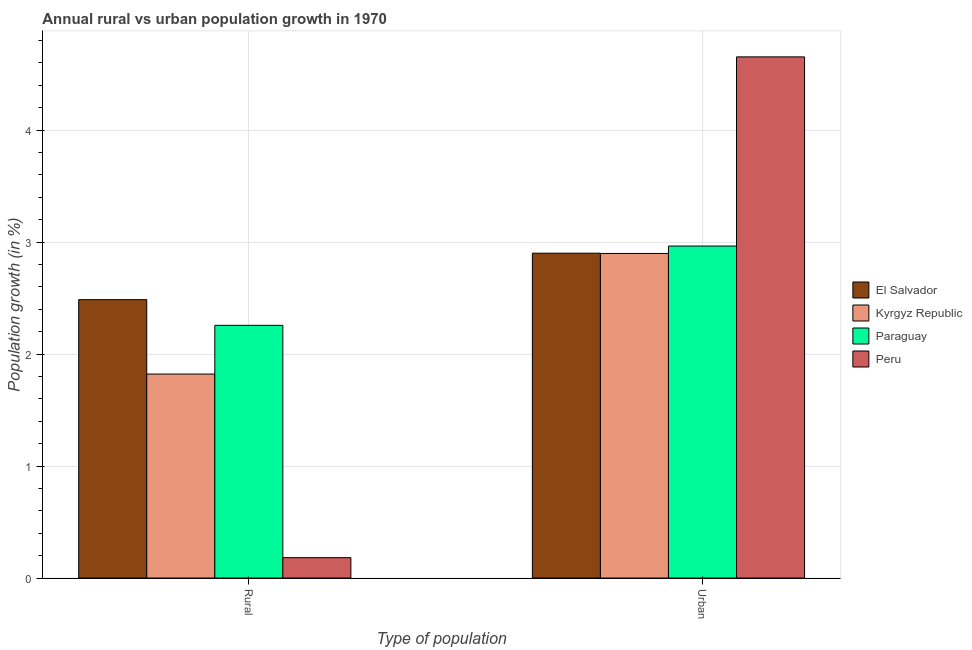How many different coloured bars are there?
Provide a short and direct response. 4. How many groups of bars are there?
Offer a very short reply. 2. Are the number of bars on each tick of the X-axis equal?
Provide a short and direct response. Yes. How many bars are there on the 2nd tick from the left?
Your response must be concise. 4. What is the label of the 2nd group of bars from the left?
Offer a terse response. Urban . What is the rural population growth in Peru?
Your response must be concise. 0.18. Across all countries, what is the maximum urban population growth?
Keep it short and to the point. 4.65. Across all countries, what is the minimum rural population growth?
Your answer should be compact. 0.18. In which country was the rural population growth minimum?
Provide a succinct answer. Peru. What is the total rural population growth in the graph?
Give a very brief answer. 6.75. What is the difference between the urban population growth in Paraguay and that in Peru?
Your answer should be very brief. -1.69. What is the difference between the rural population growth in Peru and the urban population growth in Kyrgyz Republic?
Provide a short and direct response. -2.72. What is the average urban population growth per country?
Your answer should be very brief. 3.35. What is the difference between the urban population growth and rural population growth in El Salvador?
Provide a succinct answer. 0.41. In how many countries, is the rural population growth greater than 1.8 %?
Your answer should be compact. 3. What is the ratio of the rural population growth in El Salvador to that in Paraguay?
Offer a terse response. 1.1. What does the 3rd bar from the left in Rural represents?
Make the answer very short. Paraguay. What does the 2nd bar from the right in Rural represents?
Provide a succinct answer. Paraguay. How many bars are there?
Your response must be concise. 8. Are all the bars in the graph horizontal?
Make the answer very short. No. How many countries are there in the graph?
Offer a very short reply. 4. What is the difference between two consecutive major ticks on the Y-axis?
Your answer should be very brief. 1. Are the values on the major ticks of Y-axis written in scientific E-notation?
Offer a very short reply. No. Does the graph contain any zero values?
Offer a very short reply. No. Does the graph contain grids?
Offer a very short reply. Yes. What is the title of the graph?
Offer a terse response. Annual rural vs urban population growth in 1970. What is the label or title of the X-axis?
Provide a short and direct response. Type of population. What is the label or title of the Y-axis?
Offer a terse response. Population growth (in %). What is the Population growth (in %) of El Salvador in Rural?
Ensure brevity in your answer.  2.49. What is the Population growth (in %) in Kyrgyz Republic in Rural?
Your response must be concise. 1.82. What is the Population growth (in %) of Paraguay in Rural?
Keep it short and to the point. 2.26. What is the Population growth (in %) in Peru in Rural?
Your response must be concise. 0.18. What is the Population growth (in %) in El Salvador in Urban ?
Keep it short and to the point. 2.9. What is the Population growth (in %) in Kyrgyz Republic in Urban ?
Your answer should be very brief. 2.9. What is the Population growth (in %) in Paraguay in Urban ?
Offer a terse response. 2.96. What is the Population growth (in %) of Peru in Urban ?
Offer a terse response. 4.65. Across all Type of population, what is the maximum Population growth (in %) of El Salvador?
Give a very brief answer. 2.9. Across all Type of population, what is the maximum Population growth (in %) in Kyrgyz Republic?
Keep it short and to the point. 2.9. Across all Type of population, what is the maximum Population growth (in %) in Paraguay?
Make the answer very short. 2.96. Across all Type of population, what is the maximum Population growth (in %) in Peru?
Your answer should be very brief. 4.65. Across all Type of population, what is the minimum Population growth (in %) of El Salvador?
Keep it short and to the point. 2.49. Across all Type of population, what is the minimum Population growth (in %) of Kyrgyz Republic?
Ensure brevity in your answer.  1.82. Across all Type of population, what is the minimum Population growth (in %) in Paraguay?
Give a very brief answer. 2.26. Across all Type of population, what is the minimum Population growth (in %) in Peru?
Provide a succinct answer. 0.18. What is the total Population growth (in %) of El Salvador in the graph?
Provide a succinct answer. 5.39. What is the total Population growth (in %) of Kyrgyz Republic in the graph?
Your answer should be very brief. 4.72. What is the total Population growth (in %) in Paraguay in the graph?
Your answer should be very brief. 5.22. What is the total Population growth (in %) in Peru in the graph?
Give a very brief answer. 4.84. What is the difference between the Population growth (in %) of El Salvador in Rural and that in Urban ?
Your answer should be very brief. -0.41. What is the difference between the Population growth (in %) of Kyrgyz Republic in Rural and that in Urban ?
Your response must be concise. -1.08. What is the difference between the Population growth (in %) in Paraguay in Rural and that in Urban ?
Give a very brief answer. -0.71. What is the difference between the Population growth (in %) in Peru in Rural and that in Urban ?
Offer a very short reply. -4.47. What is the difference between the Population growth (in %) of El Salvador in Rural and the Population growth (in %) of Kyrgyz Republic in Urban?
Keep it short and to the point. -0.41. What is the difference between the Population growth (in %) in El Salvador in Rural and the Population growth (in %) in Paraguay in Urban?
Offer a very short reply. -0.48. What is the difference between the Population growth (in %) in El Salvador in Rural and the Population growth (in %) in Peru in Urban?
Your answer should be compact. -2.17. What is the difference between the Population growth (in %) in Kyrgyz Republic in Rural and the Population growth (in %) in Paraguay in Urban?
Offer a very short reply. -1.14. What is the difference between the Population growth (in %) of Kyrgyz Republic in Rural and the Population growth (in %) of Peru in Urban?
Offer a very short reply. -2.83. What is the difference between the Population growth (in %) in Paraguay in Rural and the Population growth (in %) in Peru in Urban?
Your response must be concise. -2.4. What is the average Population growth (in %) of El Salvador per Type of population?
Your answer should be compact. 2.69. What is the average Population growth (in %) in Kyrgyz Republic per Type of population?
Offer a terse response. 2.36. What is the average Population growth (in %) of Paraguay per Type of population?
Your answer should be compact. 2.61. What is the average Population growth (in %) in Peru per Type of population?
Give a very brief answer. 2.42. What is the difference between the Population growth (in %) of El Salvador and Population growth (in %) of Kyrgyz Republic in Rural?
Ensure brevity in your answer.  0.66. What is the difference between the Population growth (in %) of El Salvador and Population growth (in %) of Paraguay in Rural?
Provide a succinct answer. 0.23. What is the difference between the Population growth (in %) in El Salvador and Population growth (in %) in Peru in Rural?
Make the answer very short. 2.3. What is the difference between the Population growth (in %) in Kyrgyz Republic and Population growth (in %) in Paraguay in Rural?
Offer a very short reply. -0.43. What is the difference between the Population growth (in %) in Kyrgyz Republic and Population growth (in %) in Peru in Rural?
Offer a very short reply. 1.64. What is the difference between the Population growth (in %) of Paraguay and Population growth (in %) of Peru in Rural?
Offer a terse response. 2.07. What is the difference between the Population growth (in %) of El Salvador and Population growth (in %) of Kyrgyz Republic in Urban ?
Offer a very short reply. 0. What is the difference between the Population growth (in %) of El Salvador and Population growth (in %) of Paraguay in Urban ?
Offer a very short reply. -0.06. What is the difference between the Population growth (in %) of El Salvador and Population growth (in %) of Peru in Urban ?
Make the answer very short. -1.75. What is the difference between the Population growth (in %) in Kyrgyz Republic and Population growth (in %) in Paraguay in Urban ?
Make the answer very short. -0.07. What is the difference between the Population growth (in %) in Kyrgyz Republic and Population growth (in %) in Peru in Urban ?
Ensure brevity in your answer.  -1.76. What is the difference between the Population growth (in %) in Paraguay and Population growth (in %) in Peru in Urban ?
Offer a very short reply. -1.69. What is the ratio of the Population growth (in %) of El Salvador in Rural to that in Urban ?
Your answer should be compact. 0.86. What is the ratio of the Population growth (in %) of Kyrgyz Republic in Rural to that in Urban ?
Offer a very short reply. 0.63. What is the ratio of the Population growth (in %) of Paraguay in Rural to that in Urban ?
Keep it short and to the point. 0.76. What is the ratio of the Population growth (in %) of Peru in Rural to that in Urban ?
Provide a short and direct response. 0.04. What is the difference between the highest and the second highest Population growth (in %) of El Salvador?
Keep it short and to the point. 0.41. What is the difference between the highest and the second highest Population growth (in %) in Kyrgyz Republic?
Make the answer very short. 1.08. What is the difference between the highest and the second highest Population growth (in %) of Paraguay?
Offer a very short reply. 0.71. What is the difference between the highest and the second highest Population growth (in %) in Peru?
Offer a terse response. 4.47. What is the difference between the highest and the lowest Population growth (in %) of El Salvador?
Your response must be concise. 0.41. What is the difference between the highest and the lowest Population growth (in %) of Kyrgyz Republic?
Ensure brevity in your answer.  1.08. What is the difference between the highest and the lowest Population growth (in %) of Paraguay?
Give a very brief answer. 0.71. What is the difference between the highest and the lowest Population growth (in %) of Peru?
Your response must be concise. 4.47. 